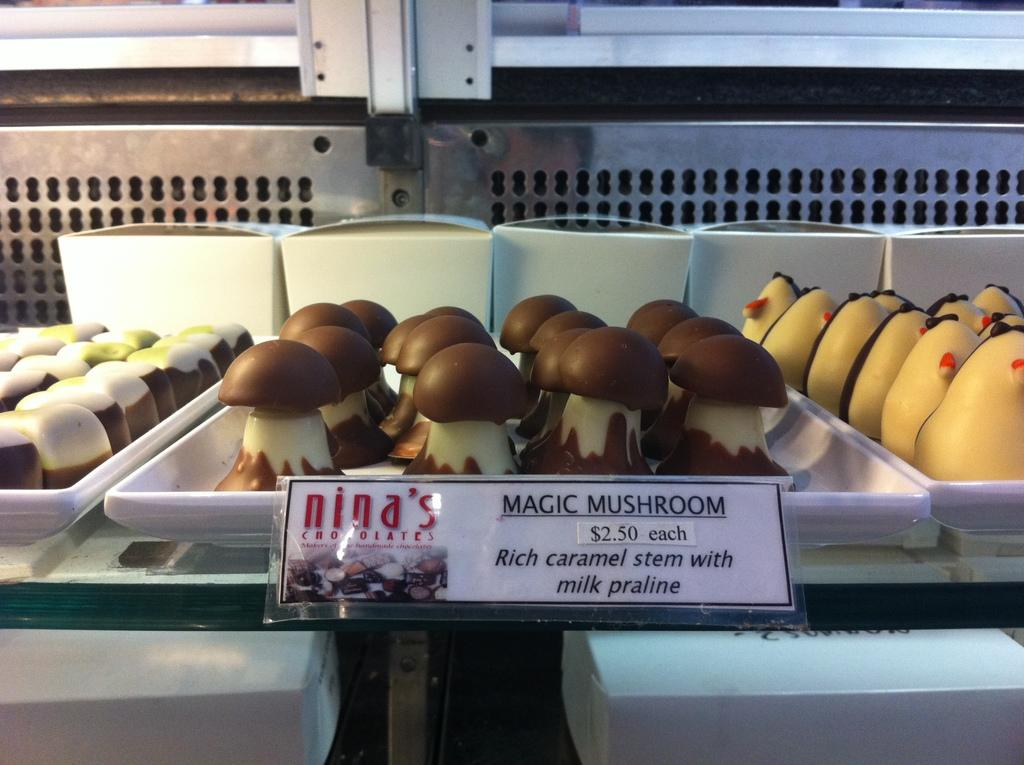What can be seen in the image in terms of containers? There are many trays in the image. What is the color of the trays? The trays are white in color. What is placed on the trays? There are food items of different colors and shapes on the trays. How can one identify the specific food items on the trays? There is a name and price tag associated with the food items. What type of pancake is being used as a volleyball in the image? There is no pancake or volleyball present in the image. What is the lead content of the food items on the trays? The provided facts do not mention anything about the lead content of the food items, so it cannot be determined from the image. 